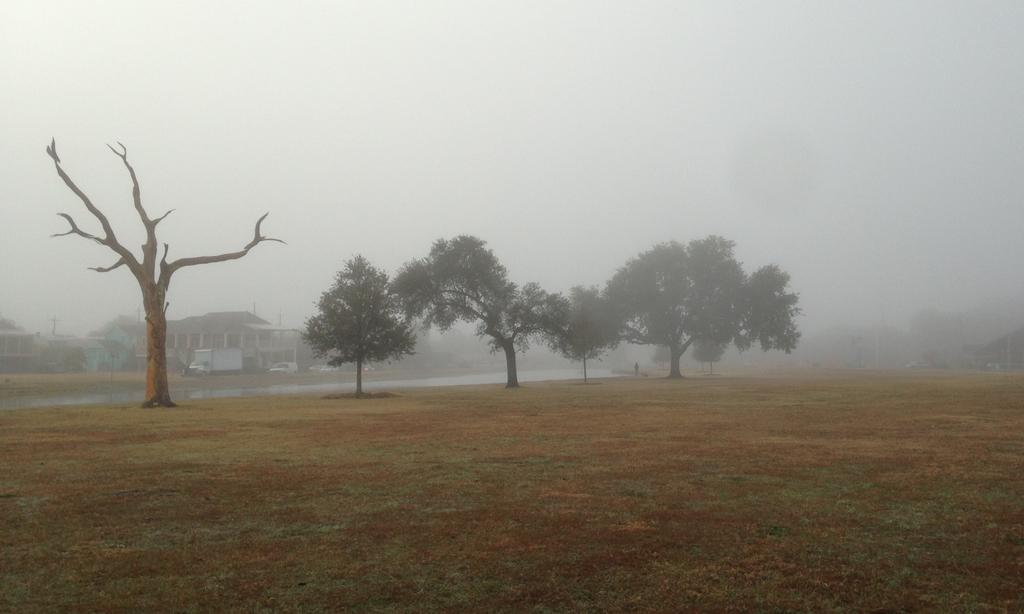What type of terrain is visible in the image? There is ground visible in the image, and there is grass as well. What other natural elements can be seen in the image? There are trees and water visible in the image. Is there any sign of human presence in the image? Yes, there is a person in the image. What can be seen in the background of the image? There are houses and the sky visible in the background of the image. What type of oatmeal is the person eating in the image? There is no oatmeal present in the image; the person is not eating anything. Can you describe the woman in the image? There is no woman in the image; the person present is not specified as male or female. 